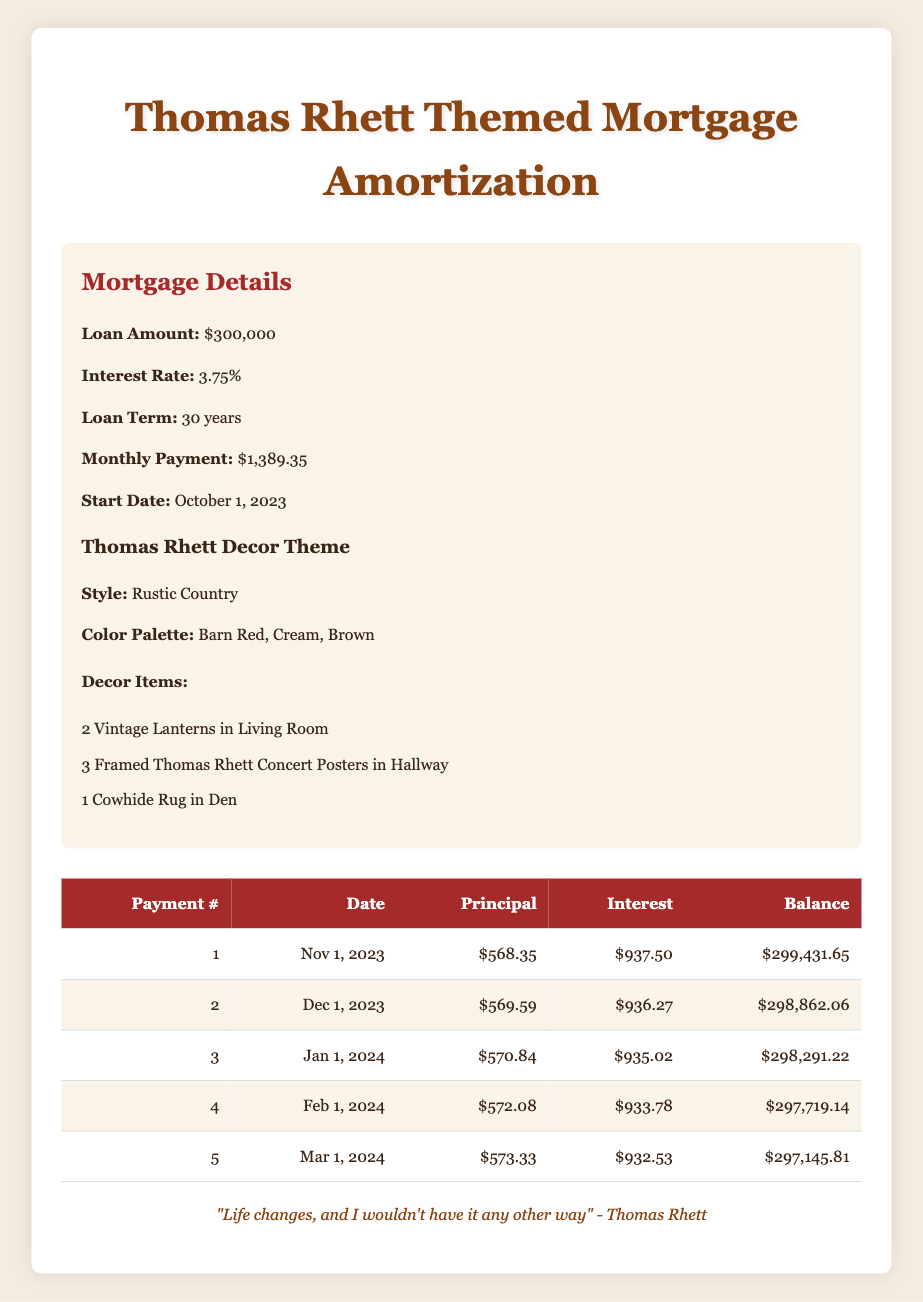What is the total principal payment made in the first five months? The principal payments for the first five months are 568.35, 569.59, 570.84, 572.08, and 573.33. Adding these together gives a total of 568.35 + 569.59 + 570.84 + 572.08 + 573.33 = 2864.19.
Answer: 2864.19 What is the interest payment for the third month? The interest payment for the third month is listed as 935.02 in the table.
Answer: 935.02 Is the remaining balance after the second payment less than $298,500? The remaining balance after the second payment is 298862.06, which is greater than 298500. Therefore, the statement is false.
Answer: No Which month requires the highest total payment to principal and interest? The total payments for the first five months can be found by adding each month's principal and interest payments. Doing this: (568.35 + 937.50), (569.59 + 936.27), (570.84 + 935.02), (572.08 + 933.78), and (573.33 + 932.53) gives us totals of 1505.85, 1505.86, 1505.86, 1505.86, and 1505.86 respectively. The highest total payment occurs in the first month.
Answer: First month What is the average principal payment for the first five months? To find the average principal payment, we first sum the principal payments: 568.35 + 569.59 + 570.84 + 572.08 + 573.33 = 2864.19. Next, we divide this sum by the number of payments, which is 5. Thus, the average principal payment is 2864.19 / 5 = 572.84.
Answer: 572.84 What is the total remaining balance after the fourth payment? The remaining balance after the fourth payment is provided in the table as 297719.14.
Answer: 297719.14 